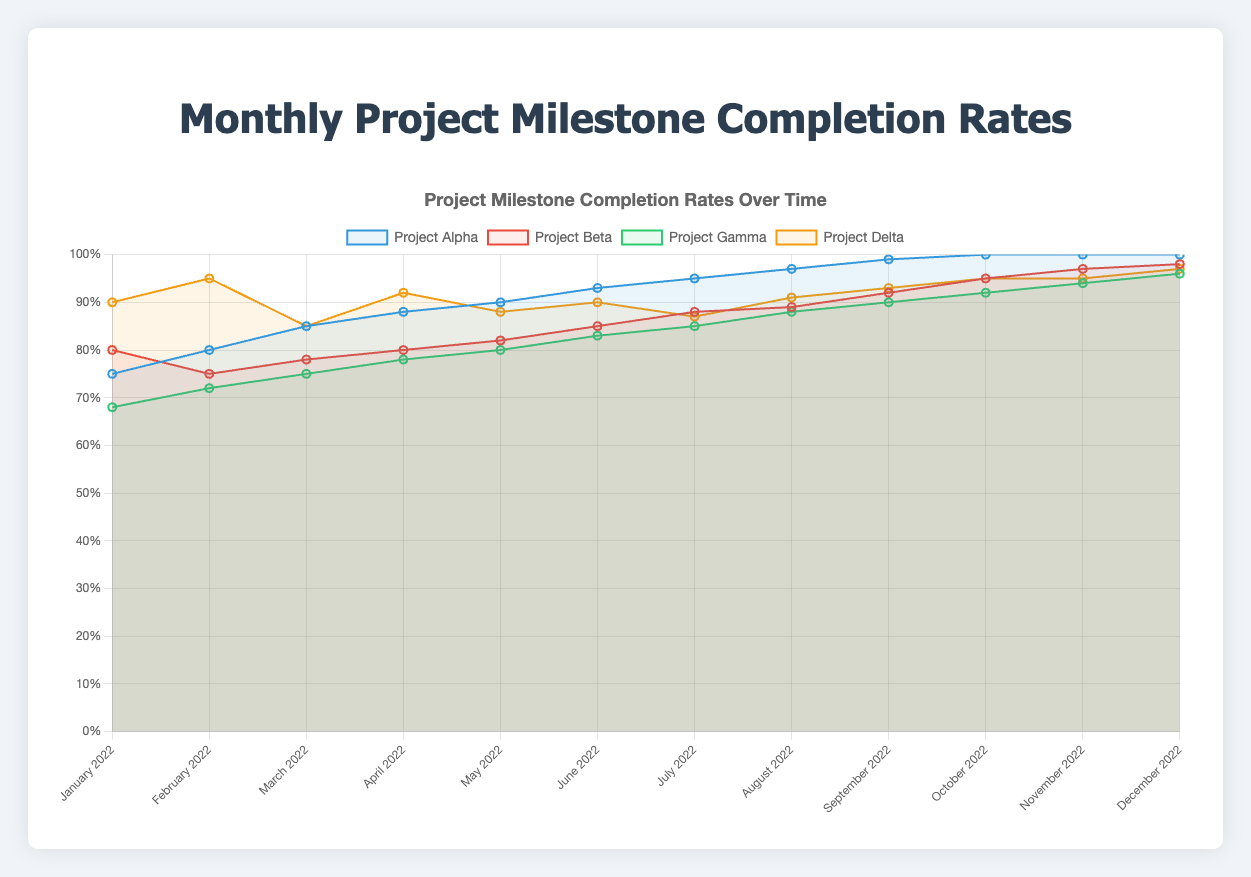Which project had the highest milestone completion rate in January 2022? By looking at the data for January 2022, the project with the highest completion rate is identified. Project Alpha has 75%, Project Beta 80%, Project Gamma 68%, and Project Delta 90%. Thus, Project Delta has the highest completion rate.
Answer: Project Delta Which month shows the highest milestone completion rate for Project Beta? Review Project Beta's milestone completion rates over each month and identify the highest value. The values are 80, 75, 78, 80, 82, 85, 88, 89, 92, 95, 97, and 98. The highest value is 98%, appearing in December 2022.
Answer: December 2022 What is the average milestone completion rate for Project Gamma in the first quarter of 2022? Calculate the average by summing the completion rates for January, February, and March, then divide by 3. The values are 68, 72, and 75. (68 + 72 + 75) / 3 = 215 / 3 ≈ 71.67.
Answer: 71.67 How does Project Alpha's trend compare to Project Delta's trend throughout 2022? Compare the completion rates of Project Alpha and Project Delta across all months. Project Alpha's values increase consistently from 75 to 100, while Project Delta fluctuates slightly but remains high, starting at 90 and ending at 97. Alpha generally shows a steady increase, while Delta experiences some variance.
Answer: Project Alpha shows a steady increase; Project Delta fluctuates but remains high What is the difference in milestone completion rates between Project Gamma and Project Delta in March 2022? Locate the completion rates for both projects in March 2022 (Project Gamma 75%, Project Delta 85%) and find the difference. 85 - 75 = 10.
Answer: 10% Which project had the smallest improvement in milestone completion rate from January to December 2022? Calculate the difference in completion rates between January and December for all projects. Project Alpha: 100 - 75 = 25, Project Beta: 98 - 80 = 18, Project Gamma: 96 - 68 = 28, Project Delta: 97 - 90 = 7. The smallest improvement is observed in Project Delta.
Answer: Project Delta In which month did Project Alpha reach a 95% completion rate? Check Project Alpha's completion rates each month. Project Alpha reached a 95% completion rate in July 2022.
Answer: July 2022 What is the median completion rate for Project Delta from January to June 2022? Identify the completion rates for Project Delta for these months: 90, 95, 85, 92, 88, 90. Sort these values (85, 88, 90, 90, 92, 95) and find the median, which is the average of the 3rd and 4th values: (90 + 90) / 2 = 90.
Answer: 90 Which month had the greatest overall variation in milestone completion rates among all projects? Calculate the range (difference between max and min) of completion rates among all projects for each month. January: 90-68=22, February: 95-72=23, March: 85-75=10, April: 92-78=14, May: 90-80=10, June: 93-83=10, July: 95-85=10, August: 97-88=9, September: 99-90=9, October: 100-92=8, November: 100-94=6, December: 100-96=4. The greatest variation is in February.
Answer: February 2022 How many projects achieved a 100% milestone completion rate by December 2022? Review the completion rates of all projects in December 2022. Project Alpha is at 100%, Project Beta at 98%, Project Gamma at 96%, and Project Delta at 97%. Only Project Alpha reached 100%.
Answer: 1 